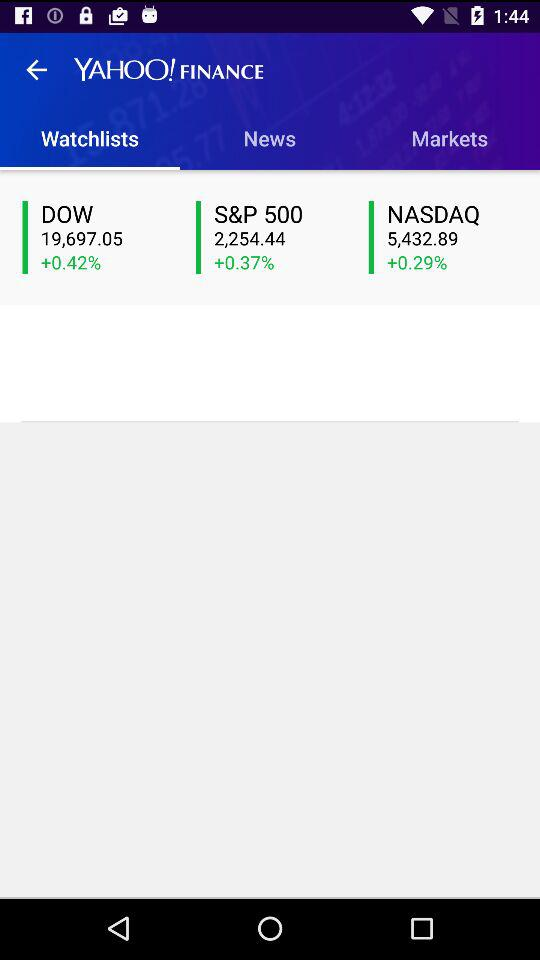Which index is up the most, the S&P 500 or the NASDAQ?
Answer the question using a single word or phrase. S&P 500 